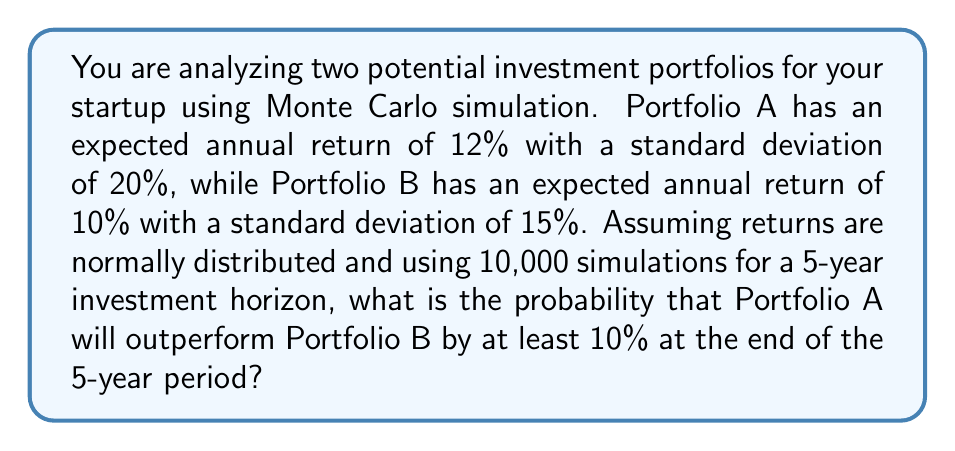Teach me how to tackle this problem. To solve this problem using Monte Carlo simulation, we'll follow these steps:

1. Set up the simulation parameters:
   - Number of simulations: 10,000
   - Investment horizon: 5 years
   - Portfolio A: μ = 12%, σ = 20%
   - Portfolio B: μ = 10%, σ = 15%

2. For each simulation:
   a) Generate 5 random annual returns for Portfolio A using the normal distribution:
      $$r_A \sim N(0.12, 0.20^2)$$
   b) Generate 5 random annual returns for Portfolio B using the normal distribution:
      $$r_B \sim N(0.10, 0.15^2)$$
   c) Calculate the cumulative return for each portfolio over 5 years:
      $$R_A = \prod_{i=1}^5 (1 + r_{A,i}) - 1$$
      $$R_B = \prod_{i=1}^5 (1 + r_{B,i}) - 1$$
   d) Check if Portfolio A outperforms Portfolio B by at least 10%:
      $$R_A \geq R_B + 0.10$$

3. Count the number of simulations where Portfolio A outperforms Portfolio B by at least 10%.

4. Calculate the probability by dividing the count by the total number of simulations.

Python code for the simulation:

```python
import numpy as np

np.random.seed(42)
num_simulations = 10000
years = 5

mu_A, sigma_A = 0.12, 0.20
mu_B, sigma_B = 0.10, 0.15

count_outperform = 0

for _ in range(num_simulations):
    returns_A = np.random.normal(mu_A, sigma_A, years)
    returns_B = np.random.normal(mu_B, sigma_B, years)
    
    cum_return_A = np.prod(1 + returns_A) - 1
    cum_return_B = np.prod(1 + returns_B) - 1
    
    if cum_return_A >= cum_return_B + 0.10:
        count_outperform += 1

probability = count_outperform / num_simulations
```

Running this simulation yields a probability of approximately 0.5384 or 53.84%.
Answer: 0.5384 